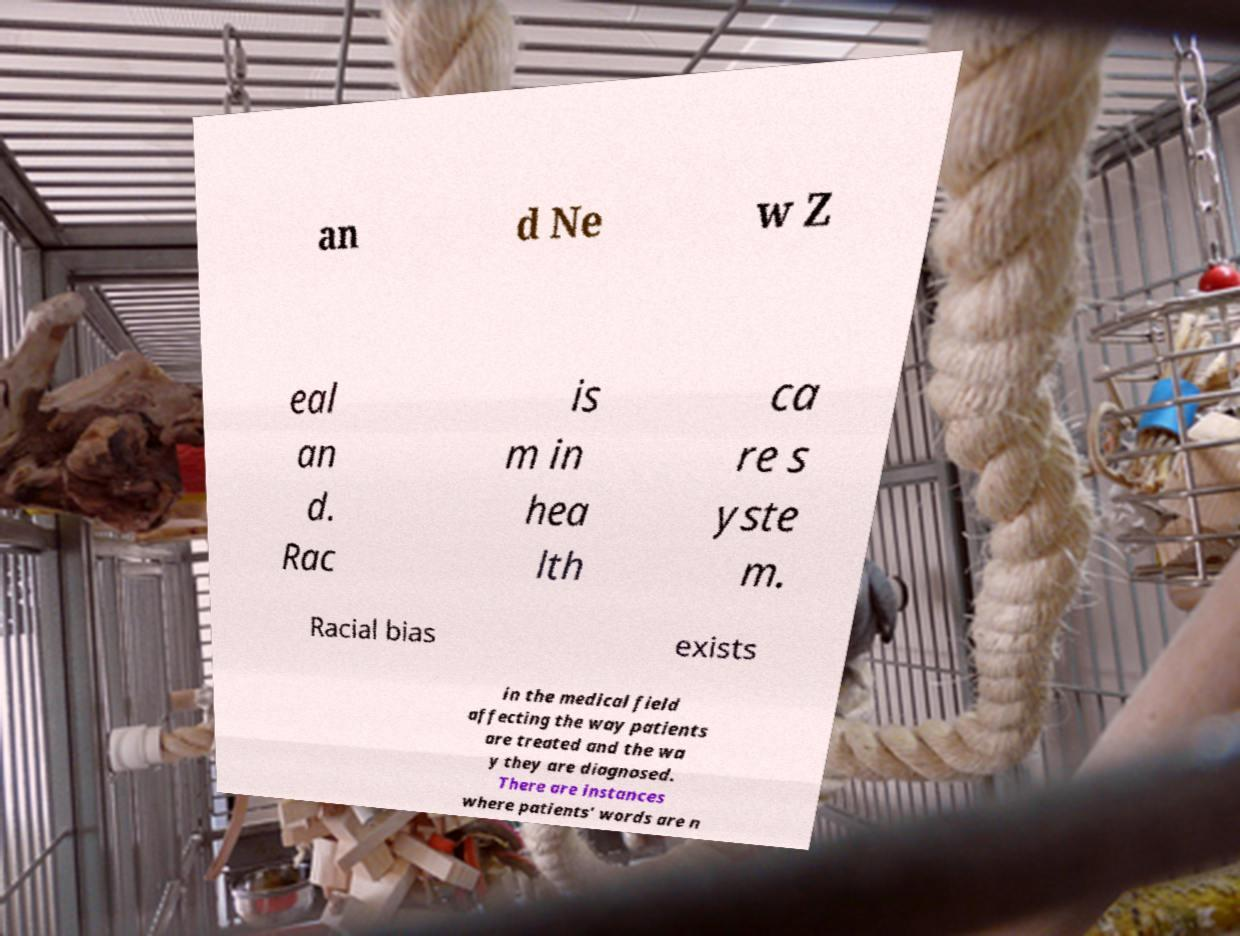What messages or text are displayed in this image? I need them in a readable, typed format. an d Ne w Z eal an d. Rac is m in hea lth ca re s yste m. Racial bias exists in the medical field affecting the way patients are treated and the wa y they are diagnosed. There are instances where patients’ words are n 